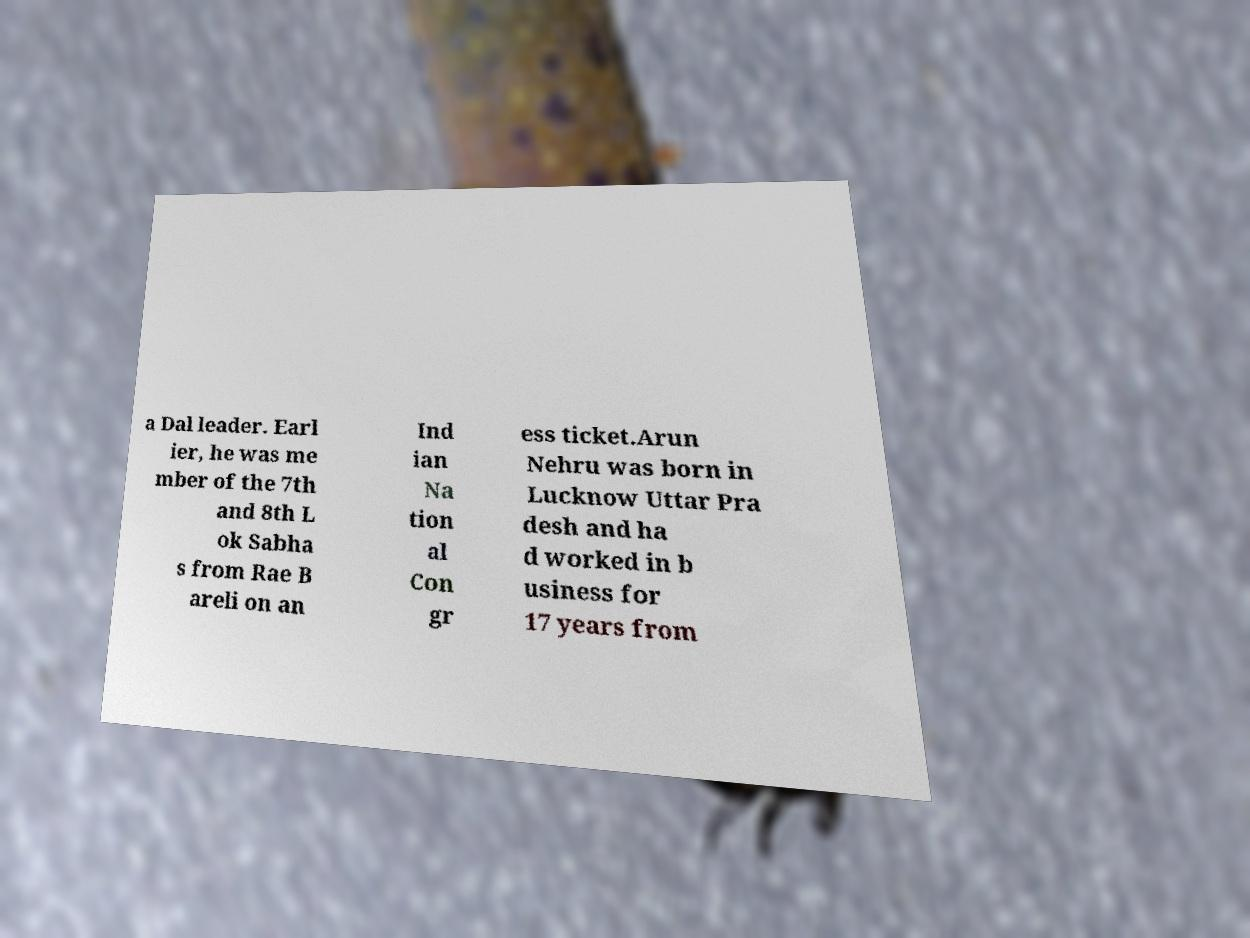Please read and relay the text visible in this image. What does it say? a Dal leader. Earl ier, he was me mber of the 7th and 8th L ok Sabha s from Rae B areli on an Ind ian Na tion al Con gr ess ticket.Arun Nehru was born in Lucknow Uttar Pra desh and ha d worked in b usiness for 17 years from 